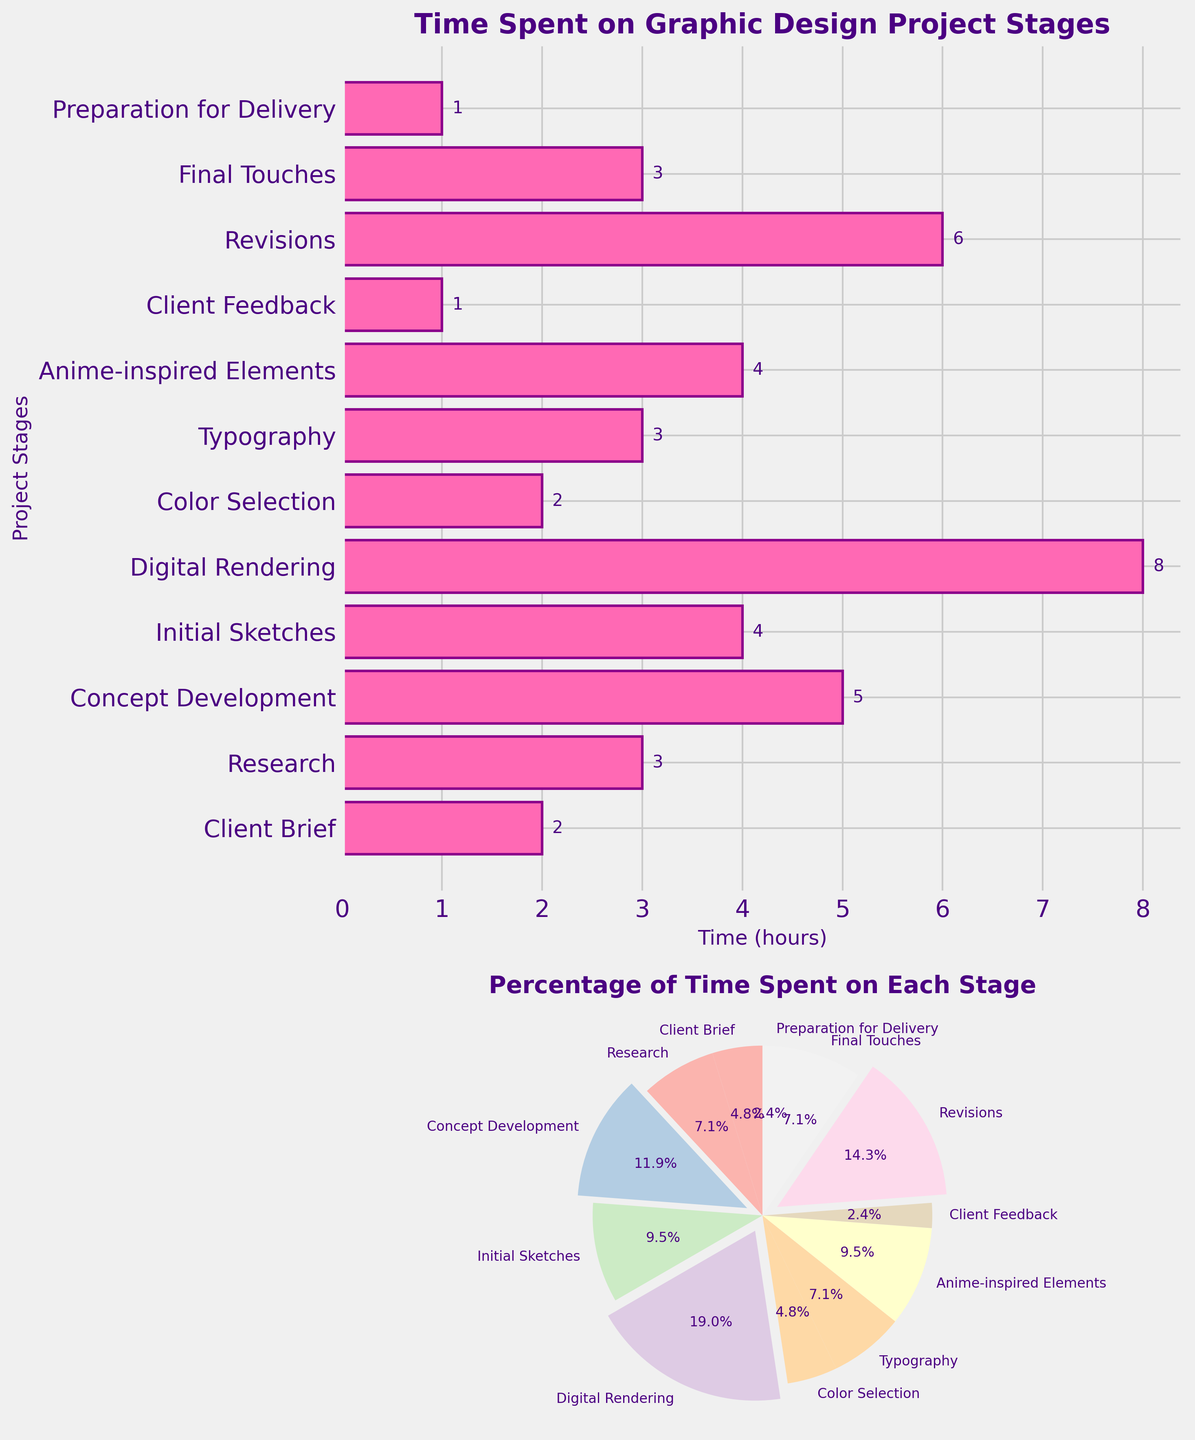What is the title of the first subplot? The title of the first subplot can be found at the top of the bar plot. It states "Time Spent on Graphic Design Project Stages".
Answer: Time Spent on Graphic Design Project Stages Which stage takes the least amount of time? The bar representing the stage with the least hours is the smallest one. The smallest bars belong to "Client Feedback" and "Preparation for Delivery", both with 1 hour each.
Answer: Client Feedback and Preparation for Delivery How many stages have more than 4 hours spent on them? Count the bars with lengths greater than 4 hours. These stages are "Concept Development" (5 hours), "Digital Rendering" (8 hours), and "Revisions" (6 hours).
Answer: Three stages What percentage of the total project time is spent on Digital Rendering? To calculate this, find the slice of the pie chart for "Digital Rendering" and examine its percentage, which is highlighted with an exploded slice. The label shows it as "28.6%".
Answer: 28.6% Which stage has nearly the same time allocation as "Anime-inspired Elements"? Compare the hours on the bar plot. "Initial Sketches" also has 4 hours, the same as "Anime-inspired Elements".
Answer: Initial Sketches What is the total amount of hours spent across all stages? Sum the hours listed for all stages. The total time is calculated as 2 + 3 + 5 + 4 + 8 + 2 + 3 + 4 + 1 + 6 + 3 + 1 = 42 hours.
Answer: 42 hours Which stage occupies the largest slice in the pie chart? The largest slice is visually prominent and exploded. "Digital Rendering" has the largest slice, corresponding to 28.6%.
Answer: Digital Rendering How does the time spent on Revisions compare to the time spent on Research? In the bar plot, "Revisions" has 6 hours and "Research" has 3 hours. 6 hours is double the time spent on 3 hours.
Answer: Revisions has 2x more time What is the second largest time investment according to the pie chart? By observing the size of the slices, the second largest slice after "Digital Rendering" is for "Revisions", occupying 14.3%.
Answer: Revisions How many stages have an equal time investment of 3 hours? Check for bars that denote exactly 3 hours. The stages with 3 hours are "Research", "Typography", and "Final Touches", totaling to three stages.
Answer: Three stages 